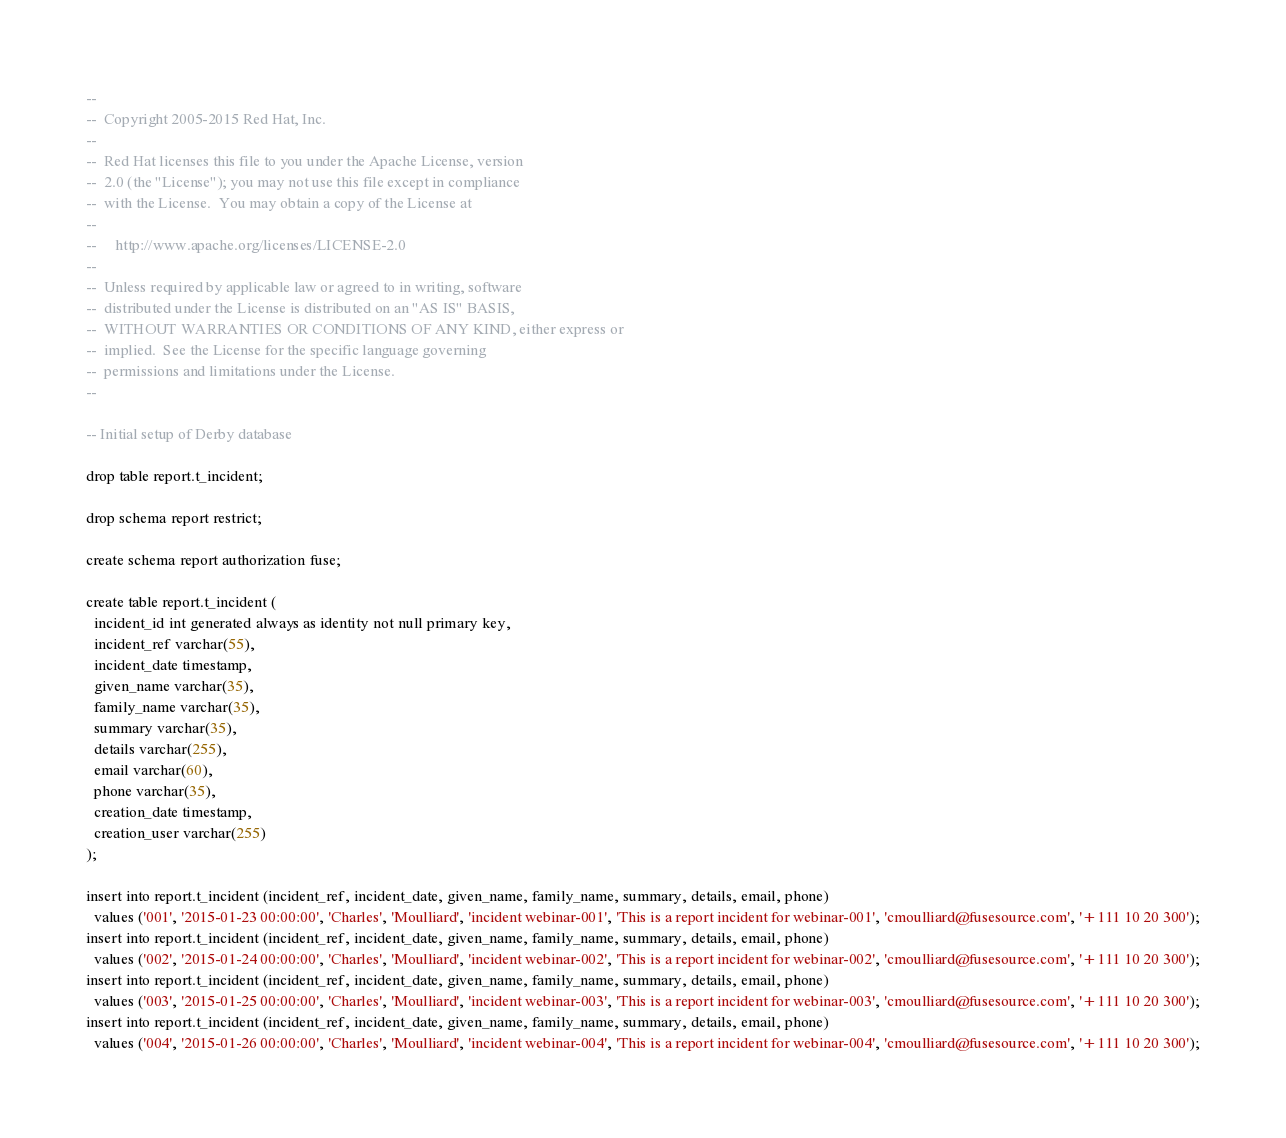Convert code to text. <code><loc_0><loc_0><loc_500><loc_500><_SQL_>--
--  Copyright 2005-2015 Red Hat, Inc.
--
--  Red Hat licenses this file to you under the Apache License, version
--  2.0 (the "License"); you may not use this file except in compliance
--  with the License.  You may obtain a copy of the License at
--
--     http://www.apache.org/licenses/LICENSE-2.0
--
--  Unless required by applicable law or agreed to in writing, software
--  distributed under the License is distributed on an "AS IS" BASIS,
--  WITHOUT WARRANTIES OR CONDITIONS OF ANY KIND, either express or
--  implied.  See the License for the specific language governing
--  permissions and limitations under the License.
--

-- Initial setup of Derby database

drop table report.t_incident;

drop schema report restrict;

create schema report authorization fuse;

create table report.t_incident (
  incident_id int generated always as identity not null primary key,
  incident_ref varchar(55),
  incident_date timestamp,
  given_name varchar(35),
  family_name varchar(35),
  summary varchar(35),
  details varchar(255),
  email varchar(60),
  phone varchar(35),
  creation_date timestamp,
  creation_user varchar(255)
);

insert into report.t_incident (incident_ref, incident_date, given_name, family_name, summary, details, email, phone)
  values ('001', '2015-01-23 00:00:00', 'Charles', 'Moulliard', 'incident webinar-001', 'This is a report incident for webinar-001', 'cmoulliard@fusesource.com', '+111 10 20 300');
insert into report.t_incident (incident_ref, incident_date, given_name, family_name, summary, details, email, phone)
  values ('002', '2015-01-24 00:00:00', 'Charles', 'Moulliard', 'incident webinar-002', 'This is a report incident for webinar-002', 'cmoulliard@fusesource.com', '+111 10 20 300');
insert into report.t_incident (incident_ref, incident_date, given_name, family_name, summary, details, email, phone)
  values ('003', '2015-01-25 00:00:00', 'Charles', 'Moulliard', 'incident webinar-003', 'This is a report incident for webinar-003', 'cmoulliard@fusesource.com', '+111 10 20 300');
insert into report.t_incident (incident_ref, incident_date, given_name, family_name, summary, details, email, phone)
  values ('004', '2015-01-26 00:00:00', 'Charles', 'Moulliard', 'incident webinar-004', 'This is a report incident for webinar-004', 'cmoulliard@fusesource.com', '+111 10 20 300');
</code> 